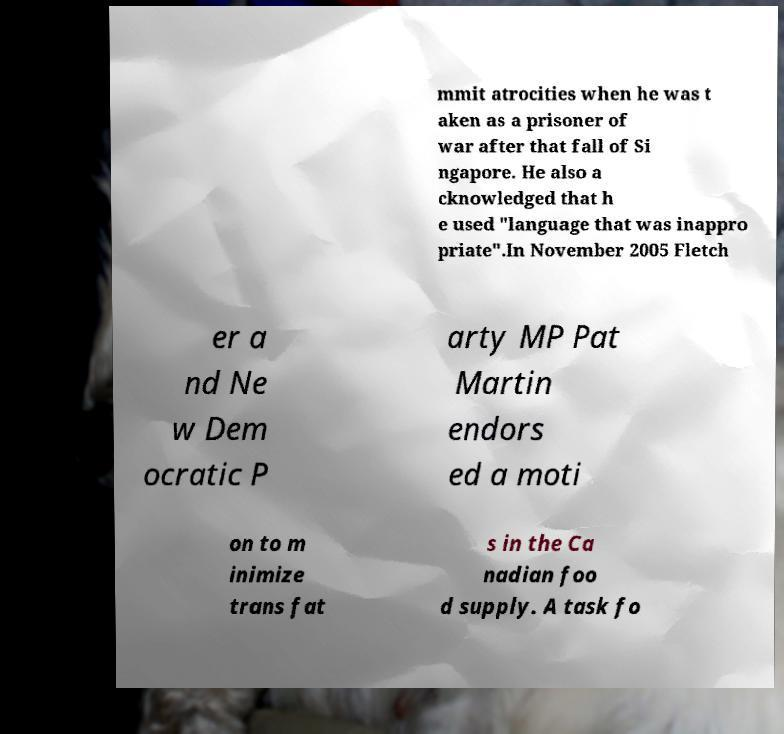Please identify and transcribe the text found in this image. mmit atrocities when he was t aken as a prisoner of war after that fall of Si ngapore. He also a cknowledged that h e used "language that was inappro priate".In November 2005 Fletch er a nd Ne w Dem ocratic P arty MP Pat Martin endors ed a moti on to m inimize trans fat s in the Ca nadian foo d supply. A task fo 